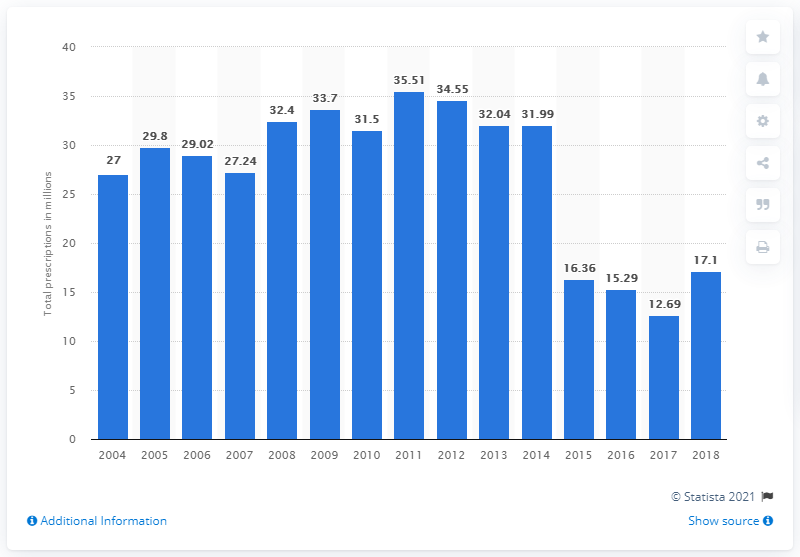Identify some key points in this picture. In 2004, azithromycin was prescribed a total of 27 times. In 2018, there were 17.1 azithromycin prescriptions. 